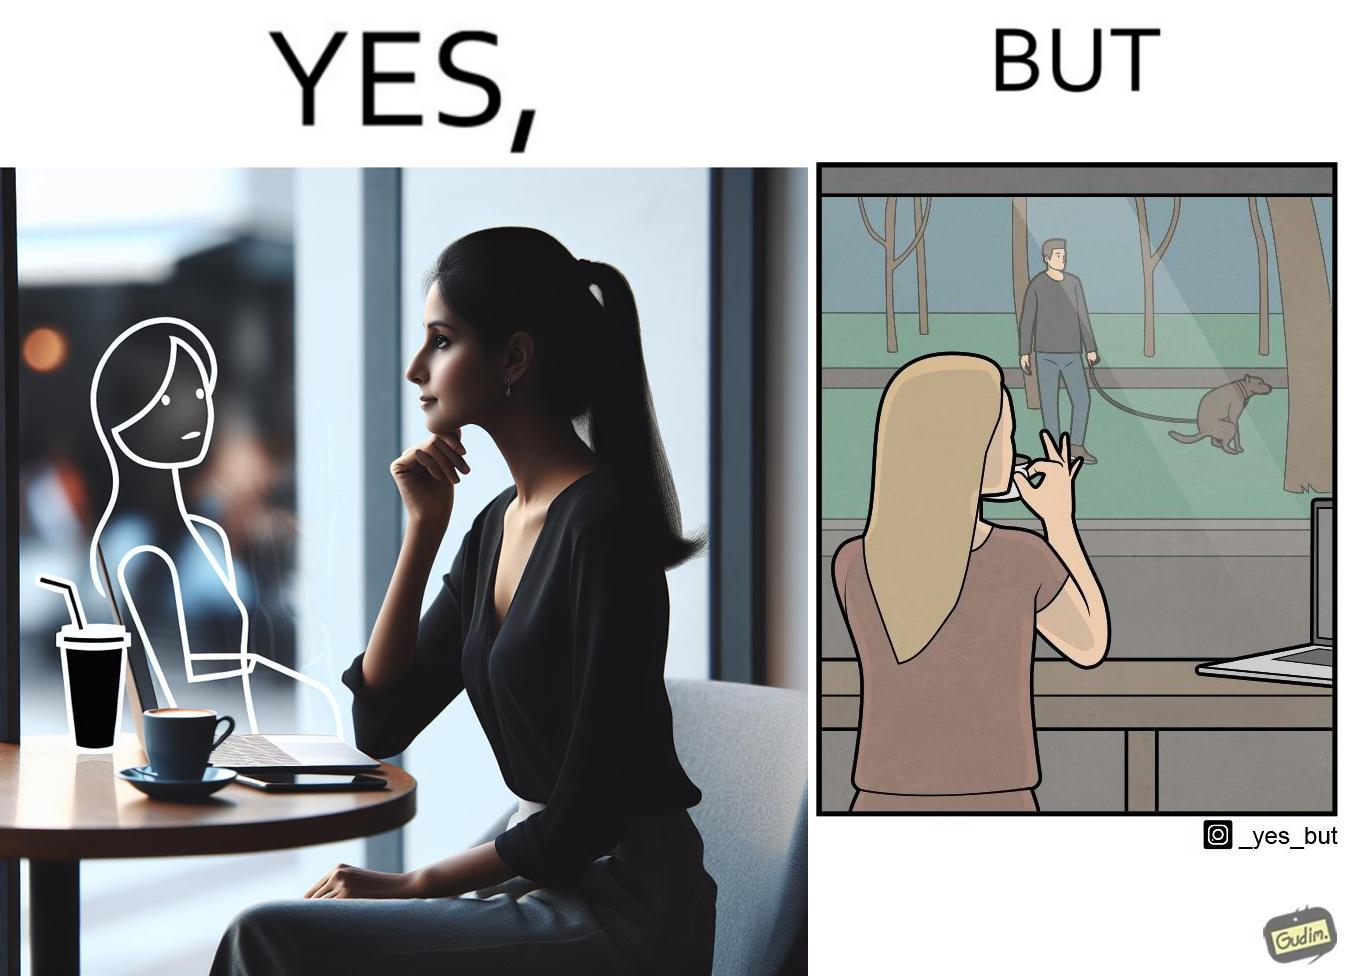Would you classify this image as satirical? Yes, this image is satirical. 